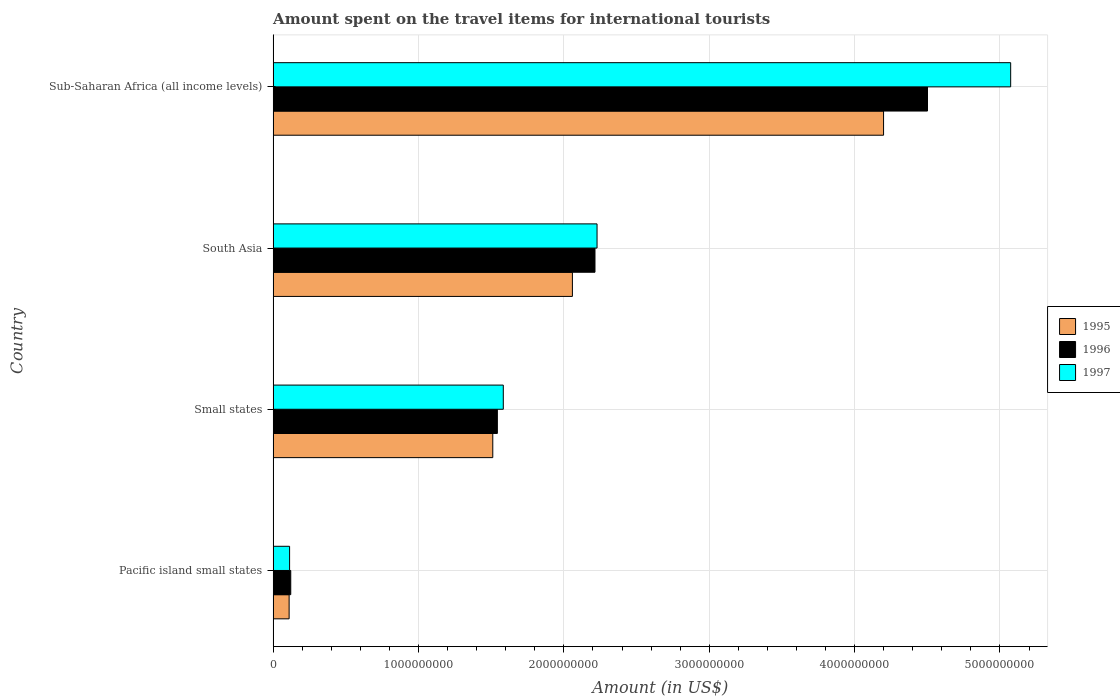Are the number of bars on each tick of the Y-axis equal?
Provide a short and direct response. Yes. How many bars are there on the 3rd tick from the top?
Your response must be concise. 3. How many bars are there on the 3rd tick from the bottom?
Provide a succinct answer. 3. What is the label of the 1st group of bars from the top?
Ensure brevity in your answer.  Sub-Saharan Africa (all income levels). What is the amount spent on the travel items for international tourists in 1996 in South Asia?
Your answer should be compact. 2.21e+09. Across all countries, what is the maximum amount spent on the travel items for international tourists in 1997?
Your answer should be compact. 5.07e+09. Across all countries, what is the minimum amount spent on the travel items for international tourists in 1995?
Ensure brevity in your answer.  1.10e+08. In which country was the amount spent on the travel items for international tourists in 1995 maximum?
Your answer should be very brief. Sub-Saharan Africa (all income levels). In which country was the amount spent on the travel items for international tourists in 1995 minimum?
Provide a short and direct response. Pacific island small states. What is the total amount spent on the travel items for international tourists in 1995 in the graph?
Give a very brief answer. 7.88e+09. What is the difference between the amount spent on the travel items for international tourists in 1997 in Pacific island small states and that in South Asia?
Ensure brevity in your answer.  -2.12e+09. What is the difference between the amount spent on the travel items for international tourists in 1997 in Pacific island small states and the amount spent on the travel items for international tourists in 1995 in Sub-Saharan Africa (all income levels)?
Give a very brief answer. -4.09e+09. What is the average amount spent on the travel items for international tourists in 1995 per country?
Make the answer very short. 1.97e+09. What is the difference between the amount spent on the travel items for international tourists in 1995 and amount spent on the travel items for international tourists in 1996 in South Asia?
Make the answer very short. -1.55e+08. In how many countries, is the amount spent on the travel items for international tourists in 1995 greater than 3600000000 US$?
Offer a very short reply. 1. What is the ratio of the amount spent on the travel items for international tourists in 1995 in Pacific island small states to that in Sub-Saharan Africa (all income levels)?
Provide a succinct answer. 0.03. Is the amount spent on the travel items for international tourists in 1995 in Pacific island small states less than that in South Asia?
Your answer should be compact. Yes. Is the difference between the amount spent on the travel items for international tourists in 1995 in Pacific island small states and South Asia greater than the difference between the amount spent on the travel items for international tourists in 1996 in Pacific island small states and South Asia?
Provide a short and direct response. Yes. What is the difference between the highest and the second highest amount spent on the travel items for international tourists in 1995?
Give a very brief answer. 2.14e+09. What is the difference between the highest and the lowest amount spent on the travel items for international tourists in 1995?
Provide a short and direct response. 4.09e+09. What does the 2nd bar from the bottom in Small states represents?
Your answer should be compact. 1996. Are all the bars in the graph horizontal?
Give a very brief answer. Yes. Does the graph contain any zero values?
Provide a short and direct response. No. How are the legend labels stacked?
Your response must be concise. Vertical. What is the title of the graph?
Give a very brief answer. Amount spent on the travel items for international tourists. Does "2013" appear as one of the legend labels in the graph?
Your answer should be compact. No. What is the label or title of the Y-axis?
Make the answer very short. Country. What is the Amount (in US$) in 1995 in Pacific island small states?
Keep it short and to the point. 1.10e+08. What is the Amount (in US$) of 1996 in Pacific island small states?
Ensure brevity in your answer.  1.21e+08. What is the Amount (in US$) of 1997 in Pacific island small states?
Your response must be concise. 1.13e+08. What is the Amount (in US$) in 1995 in Small states?
Your answer should be compact. 1.51e+09. What is the Amount (in US$) of 1996 in Small states?
Your answer should be compact. 1.54e+09. What is the Amount (in US$) in 1997 in Small states?
Make the answer very short. 1.58e+09. What is the Amount (in US$) of 1995 in South Asia?
Offer a very short reply. 2.06e+09. What is the Amount (in US$) of 1996 in South Asia?
Your answer should be compact. 2.21e+09. What is the Amount (in US$) in 1997 in South Asia?
Provide a succinct answer. 2.23e+09. What is the Amount (in US$) of 1995 in Sub-Saharan Africa (all income levels)?
Offer a very short reply. 4.20e+09. What is the Amount (in US$) of 1996 in Sub-Saharan Africa (all income levels)?
Keep it short and to the point. 4.50e+09. What is the Amount (in US$) of 1997 in Sub-Saharan Africa (all income levels)?
Keep it short and to the point. 5.07e+09. Across all countries, what is the maximum Amount (in US$) in 1995?
Provide a succinct answer. 4.20e+09. Across all countries, what is the maximum Amount (in US$) of 1996?
Keep it short and to the point. 4.50e+09. Across all countries, what is the maximum Amount (in US$) of 1997?
Provide a short and direct response. 5.07e+09. Across all countries, what is the minimum Amount (in US$) of 1995?
Provide a short and direct response. 1.10e+08. Across all countries, what is the minimum Amount (in US$) in 1996?
Your answer should be very brief. 1.21e+08. Across all countries, what is the minimum Amount (in US$) in 1997?
Provide a short and direct response. 1.13e+08. What is the total Amount (in US$) in 1995 in the graph?
Ensure brevity in your answer.  7.88e+09. What is the total Amount (in US$) in 1996 in the graph?
Your answer should be very brief. 8.38e+09. What is the total Amount (in US$) of 1997 in the graph?
Keep it short and to the point. 9.00e+09. What is the difference between the Amount (in US$) of 1995 in Pacific island small states and that in Small states?
Keep it short and to the point. -1.40e+09. What is the difference between the Amount (in US$) of 1996 in Pacific island small states and that in Small states?
Offer a terse response. -1.42e+09. What is the difference between the Amount (in US$) in 1997 in Pacific island small states and that in Small states?
Provide a succinct answer. -1.47e+09. What is the difference between the Amount (in US$) of 1995 in Pacific island small states and that in South Asia?
Offer a very short reply. -1.95e+09. What is the difference between the Amount (in US$) in 1996 in Pacific island small states and that in South Asia?
Your answer should be compact. -2.09e+09. What is the difference between the Amount (in US$) in 1997 in Pacific island small states and that in South Asia?
Your answer should be very brief. -2.12e+09. What is the difference between the Amount (in US$) of 1995 in Pacific island small states and that in Sub-Saharan Africa (all income levels)?
Give a very brief answer. -4.09e+09. What is the difference between the Amount (in US$) of 1996 in Pacific island small states and that in Sub-Saharan Africa (all income levels)?
Make the answer very short. -4.38e+09. What is the difference between the Amount (in US$) of 1997 in Pacific island small states and that in Sub-Saharan Africa (all income levels)?
Make the answer very short. -4.96e+09. What is the difference between the Amount (in US$) of 1995 in Small states and that in South Asia?
Keep it short and to the point. -5.48e+08. What is the difference between the Amount (in US$) in 1996 in Small states and that in South Asia?
Make the answer very short. -6.72e+08. What is the difference between the Amount (in US$) in 1997 in Small states and that in South Asia?
Make the answer very short. -6.45e+08. What is the difference between the Amount (in US$) in 1995 in Small states and that in Sub-Saharan Africa (all income levels)?
Your answer should be compact. -2.69e+09. What is the difference between the Amount (in US$) of 1996 in Small states and that in Sub-Saharan Africa (all income levels)?
Provide a short and direct response. -2.96e+09. What is the difference between the Amount (in US$) of 1997 in Small states and that in Sub-Saharan Africa (all income levels)?
Your answer should be compact. -3.49e+09. What is the difference between the Amount (in US$) in 1995 in South Asia and that in Sub-Saharan Africa (all income levels)?
Provide a short and direct response. -2.14e+09. What is the difference between the Amount (in US$) of 1996 in South Asia and that in Sub-Saharan Africa (all income levels)?
Provide a succinct answer. -2.29e+09. What is the difference between the Amount (in US$) in 1997 in South Asia and that in Sub-Saharan Africa (all income levels)?
Offer a terse response. -2.85e+09. What is the difference between the Amount (in US$) in 1995 in Pacific island small states and the Amount (in US$) in 1996 in Small states?
Your response must be concise. -1.43e+09. What is the difference between the Amount (in US$) in 1995 in Pacific island small states and the Amount (in US$) in 1997 in Small states?
Your response must be concise. -1.47e+09. What is the difference between the Amount (in US$) in 1996 in Pacific island small states and the Amount (in US$) in 1997 in Small states?
Offer a terse response. -1.46e+09. What is the difference between the Amount (in US$) in 1995 in Pacific island small states and the Amount (in US$) in 1996 in South Asia?
Offer a very short reply. -2.10e+09. What is the difference between the Amount (in US$) in 1995 in Pacific island small states and the Amount (in US$) in 1997 in South Asia?
Your response must be concise. -2.12e+09. What is the difference between the Amount (in US$) of 1996 in Pacific island small states and the Amount (in US$) of 1997 in South Asia?
Offer a very short reply. -2.11e+09. What is the difference between the Amount (in US$) of 1995 in Pacific island small states and the Amount (in US$) of 1996 in Sub-Saharan Africa (all income levels)?
Ensure brevity in your answer.  -4.39e+09. What is the difference between the Amount (in US$) of 1995 in Pacific island small states and the Amount (in US$) of 1997 in Sub-Saharan Africa (all income levels)?
Ensure brevity in your answer.  -4.96e+09. What is the difference between the Amount (in US$) of 1996 in Pacific island small states and the Amount (in US$) of 1997 in Sub-Saharan Africa (all income levels)?
Keep it short and to the point. -4.95e+09. What is the difference between the Amount (in US$) in 1995 in Small states and the Amount (in US$) in 1996 in South Asia?
Your answer should be compact. -7.03e+08. What is the difference between the Amount (in US$) of 1995 in Small states and the Amount (in US$) of 1997 in South Asia?
Your answer should be compact. -7.17e+08. What is the difference between the Amount (in US$) of 1996 in Small states and the Amount (in US$) of 1997 in South Asia?
Ensure brevity in your answer.  -6.86e+08. What is the difference between the Amount (in US$) of 1995 in Small states and the Amount (in US$) of 1996 in Sub-Saharan Africa (all income levels)?
Your answer should be compact. -2.99e+09. What is the difference between the Amount (in US$) in 1995 in Small states and the Amount (in US$) in 1997 in Sub-Saharan Africa (all income levels)?
Ensure brevity in your answer.  -3.56e+09. What is the difference between the Amount (in US$) in 1996 in Small states and the Amount (in US$) in 1997 in Sub-Saharan Africa (all income levels)?
Your response must be concise. -3.53e+09. What is the difference between the Amount (in US$) of 1995 in South Asia and the Amount (in US$) of 1996 in Sub-Saharan Africa (all income levels)?
Provide a succinct answer. -2.44e+09. What is the difference between the Amount (in US$) in 1995 in South Asia and the Amount (in US$) in 1997 in Sub-Saharan Africa (all income levels)?
Make the answer very short. -3.01e+09. What is the difference between the Amount (in US$) of 1996 in South Asia and the Amount (in US$) of 1997 in Sub-Saharan Africa (all income levels)?
Provide a succinct answer. -2.86e+09. What is the average Amount (in US$) in 1995 per country?
Provide a short and direct response. 1.97e+09. What is the average Amount (in US$) in 1996 per country?
Ensure brevity in your answer.  2.09e+09. What is the average Amount (in US$) in 1997 per country?
Your answer should be very brief. 2.25e+09. What is the difference between the Amount (in US$) in 1995 and Amount (in US$) in 1996 in Pacific island small states?
Give a very brief answer. -1.12e+07. What is the difference between the Amount (in US$) of 1995 and Amount (in US$) of 1997 in Pacific island small states?
Give a very brief answer. -3.22e+06. What is the difference between the Amount (in US$) in 1996 and Amount (in US$) in 1997 in Pacific island small states?
Ensure brevity in your answer.  7.98e+06. What is the difference between the Amount (in US$) in 1995 and Amount (in US$) in 1996 in Small states?
Your response must be concise. -3.15e+07. What is the difference between the Amount (in US$) in 1995 and Amount (in US$) in 1997 in Small states?
Offer a terse response. -7.24e+07. What is the difference between the Amount (in US$) in 1996 and Amount (in US$) in 1997 in Small states?
Provide a short and direct response. -4.09e+07. What is the difference between the Amount (in US$) in 1995 and Amount (in US$) in 1996 in South Asia?
Keep it short and to the point. -1.55e+08. What is the difference between the Amount (in US$) of 1995 and Amount (in US$) of 1997 in South Asia?
Provide a short and direct response. -1.69e+08. What is the difference between the Amount (in US$) of 1996 and Amount (in US$) of 1997 in South Asia?
Your answer should be very brief. -1.42e+07. What is the difference between the Amount (in US$) in 1995 and Amount (in US$) in 1996 in Sub-Saharan Africa (all income levels)?
Offer a terse response. -3.02e+08. What is the difference between the Amount (in US$) of 1995 and Amount (in US$) of 1997 in Sub-Saharan Africa (all income levels)?
Provide a short and direct response. -8.74e+08. What is the difference between the Amount (in US$) of 1996 and Amount (in US$) of 1997 in Sub-Saharan Africa (all income levels)?
Offer a very short reply. -5.72e+08. What is the ratio of the Amount (in US$) of 1995 in Pacific island small states to that in Small states?
Your answer should be compact. 0.07. What is the ratio of the Amount (in US$) in 1996 in Pacific island small states to that in Small states?
Ensure brevity in your answer.  0.08. What is the ratio of the Amount (in US$) of 1997 in Pacific island small states to that in Small states?
Provide a short and direct response. 0.07. What is the ratio of the Amount (in US$) of 1995 in Pacific island small states to that in South Asia?
Give a very brief answer. 0.05. What is the ratio of the Amount (in US$) in 1996 in Pacific island small states to that in South Asia?
Make the answer very short. 0.05. What is the ratio of the Amount (in US$) in 1997 in Pacific island small states to that in South Asia?
Keep it short and to the point. 0.05. What is the ratio of the Amount (in US$) in 1995 in Pacific island small states to that in Sub-Saharan Africa (all income levels)?
Keep it short and to the point. 0.03. What is the ratio of the Amount (in US$) in 1996 in Pacific island small states to that in Sub-Saharan Africa (all income levels)?
Your answer should be very brief. 0.03. What is the ratio of the Amount (in US$) of 1997 in Pacific island small states to that in Sub-Saharan Africa (all income levels)?
Provide a succinct answer. 0.02. What is the ratio of the Amount (in US$) of 1995 in Small states to that in South Asia?
Provide a short and direct response. 0.73. What is the ratio of the Amount (in US$) of 1996 in Small states to that in South Asia?
Your response must be concise. 0.7. What is the ratio of the Amount (in US$) of 1997 in Small states to that in South Asia?
Your response must be concise. 0.71. What is the ratio of the Amount (in US$) of 1995 in Small states to that in Sub-Saharan Africa (all income levels)?
Ensure brevity in your answer.  0.36. What is the ratio of the Amount (in US$) in 1996 in Small states to that in Sub-Saharan Africa (all income levels)?
Offer a very short reply. 0.34. What is the ratio of the Amount (in US$) of 1997 in Small states to that in Sub-Saharan Africa (all income levels)?
Your response must be concise. 0.31. What is the ratio of the Amount (in US$) in 1995 in South Asia to that in Sub-Saharan Africa (all income levels)?
Keep it short and to the point. 0.49. What is the ratio of the Amount (in US$) of 1996 in South Asia to that in Sub-Saharan Africa (all income levels)?
Provide a succinct answer. 0.49. What is the ratio of the Amount (in US$) in 1997 in South Asia to that in Sub-Saharan Africa (all income levels)?
Offer a very short reply. 0.44. What is the difference between the highest and the second highest Amount (in US$) of 1995?
Provide a succinct answer. 2.14e+09. What is the difference between the highest and the second highest Amount (in US$) of 1996?
Provide a short and direct response. 2.29e+09. What is the difference between the highest and the second highest Amount (in US$) in 1997?
Provide a short and direct response. 2.85e+09. What is the difference between the highest and the lowest Amount (in US$) in 1995?
Offer a terse response. 4.09e+09. What is the difference between the highest and the lowest Amount (in US$) in 1996?
Ensure brevity in your answer.  4.38e+09. What is the difference between the highest and the lowest Amount (in US$) in 1997?
Keep it short and to the point. 4.96e+09. 